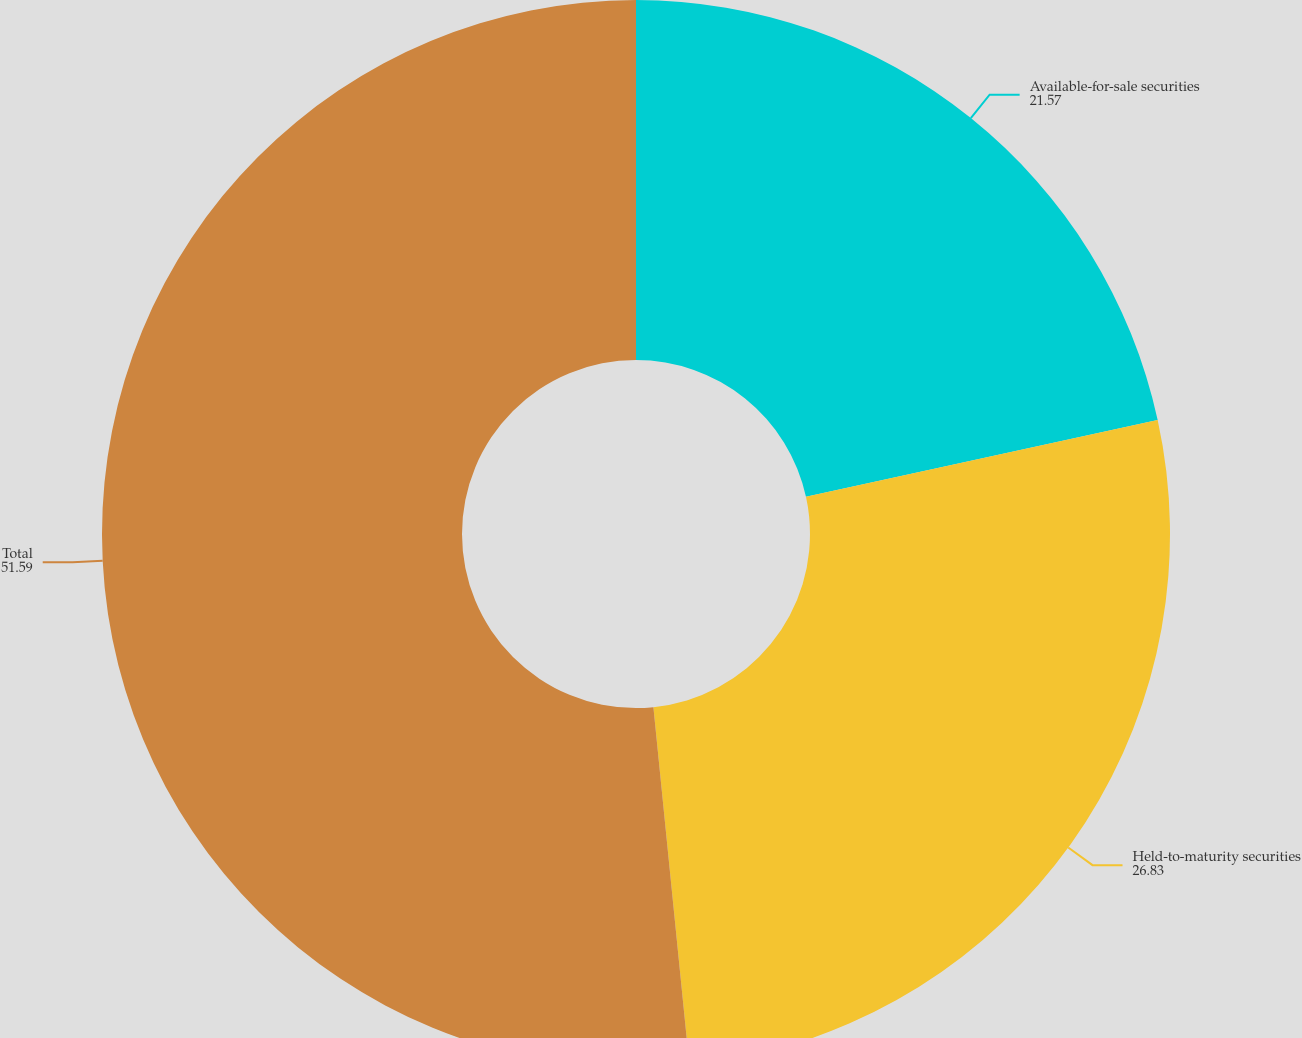Convert chart. <chart><loc_0><loc_0><loc_500><loc_500><pie_chart><fcel>Available-for-sale securities<fcel>Held-to-maturity securities<fcel>Total<nl><fcel>21.57%<fcel>26.83%<fcel>51.59%<nl></chart> 